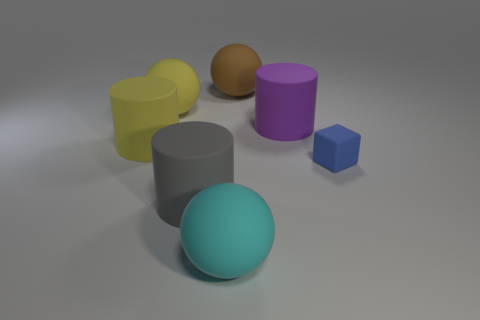Add 3 tiny matte things. How many objects exist? 10 Subtract all cylinders. How many objects are left? 4 Subtract all big rubber spheres. Subtract all metal balls. How many objects are left? 4 Add 5 rubber cylinders. How many rubber cylinders are left? 8 Add 4 yellow things. How many yellow things exist? 6 Subtract 0 purple cubes. How many objects are left? 7 